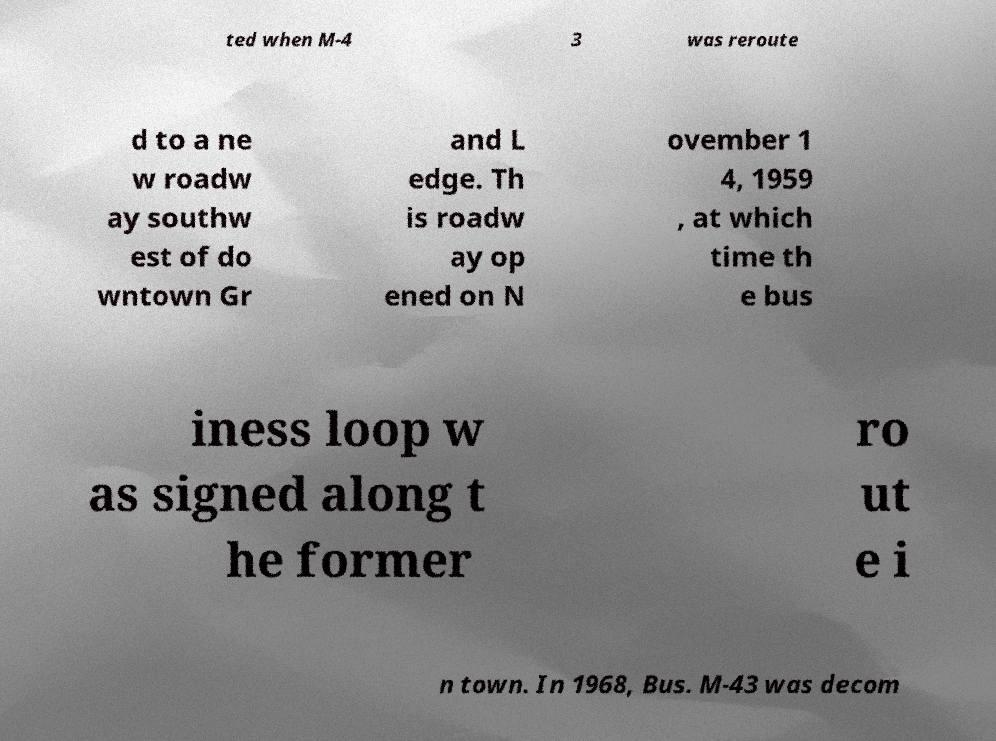I need the written content from this picture converted into text. Can you do that? ted when M-4 3 was reroute d to a ne w roadw ay southw est of do wntown Gr and L edge. Th is roadw ay op ened on N ovember 1 4, 1959 , at which time th e bus iness loop w as signed along t he former ro ut e i n town. In 1968, Bus. M-43 was decom 